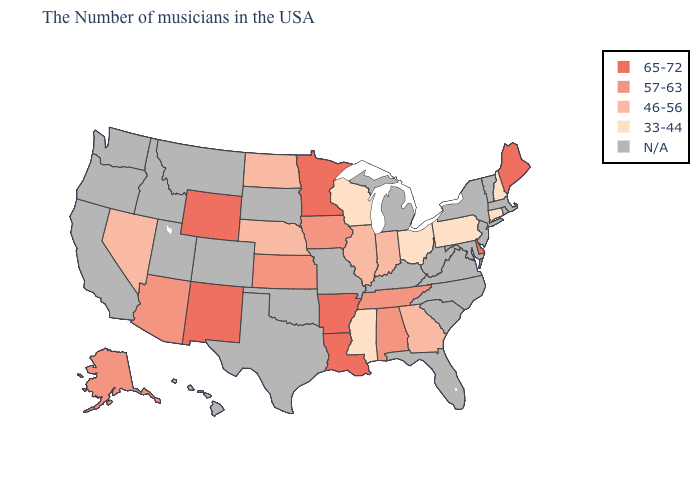Among the states that border Indiana , does Illinois have the lowest value?
Short answer required. No. How many symbols are there in the legend?
Give a very brief answer. 5. What is the value of Michigan?
Short answer required. N/A. Name the states that have a value in the range N/A?
Be succinct. Massachusetts, Rhode Island, Vermont, New York, New Jersey, Maryland, Virginia, North Carolina, South Carolina, West Virginia, Florida, Michigan, Kentucky, Missouri, Oklahoma, Texas, South Dakota, Colorado, Utah, Montana, Idaho, California, Washington, Oregon, Hawaii. Among the states that border Minnesota , does Iowa have the lowest value?
Quick response, please. No. Does Louisiana have the highest value in the USA?
Quick response, please. Yes. Does the map have missing data?
Give a very brief answer. Yes. Which states have the highest value in the USA?
Answer briefly. Maine, Delaware, Louisiana, Arkansas, Minnesota, Wyoming, New Mexico. What is the highest value in the USA?
Concise answer only. 65-72. Name the states that have a value in the range N/A?
Write a very short answer. Massachusetts, Rhode Island, Vermont, New York, New Jersey, Maryland, Virginia, North Carolina, South Carolina, West Virginia, Florida, Michigan, Kentucky, Missouri, Oklahoma, Texas, South Dakota, Colorado, Utah, Montana, Idaho, California, Washington, Oregon, Hawaii. What is the highest value in the USA?
Keep it brief. 65-72. Name the states that have a value in the range 57-63?
Quick response, please. Alabama, Tennessee, Iowa, Kansas, Arizona, Alaska. Name the states that have a value in the range 65-72?
Write a very short answer. Maine, Delaware, Louisiana, Arkansas, Minnesota, Wyoming, New Mexico. What is the value of Massachusetts?
Be succinct. N/A. 